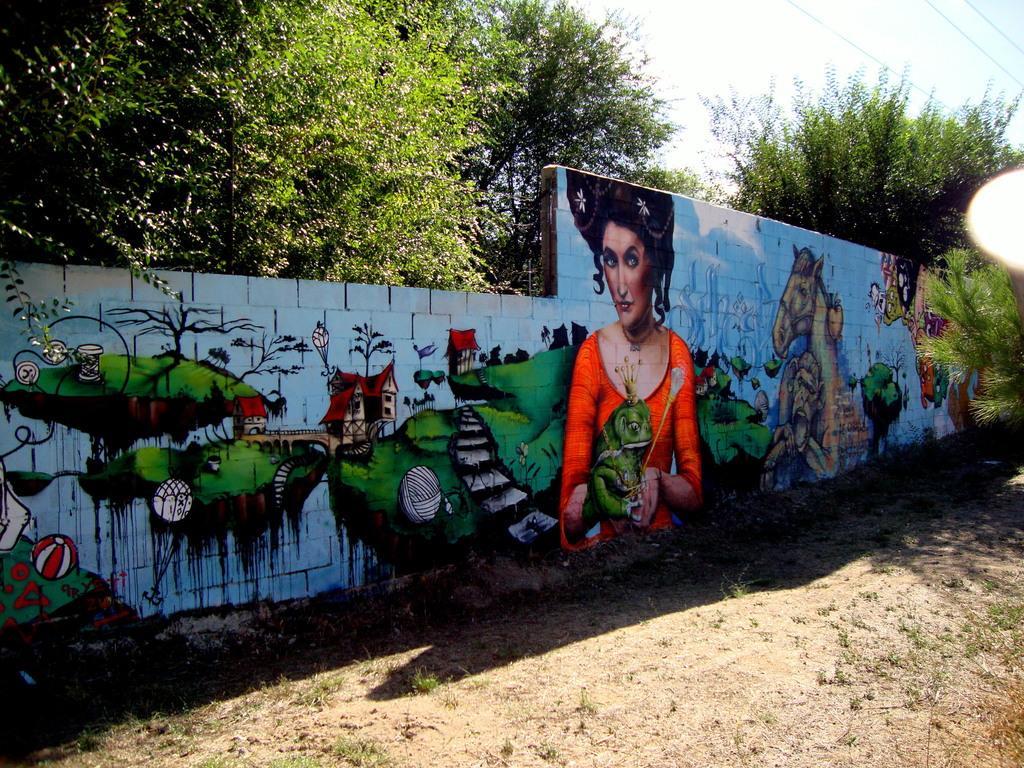Can you describe this image briefly? In this image we can see a wall which is painted with different types of images, trees, houses and in the background of the image there are some trees and clear sky. 